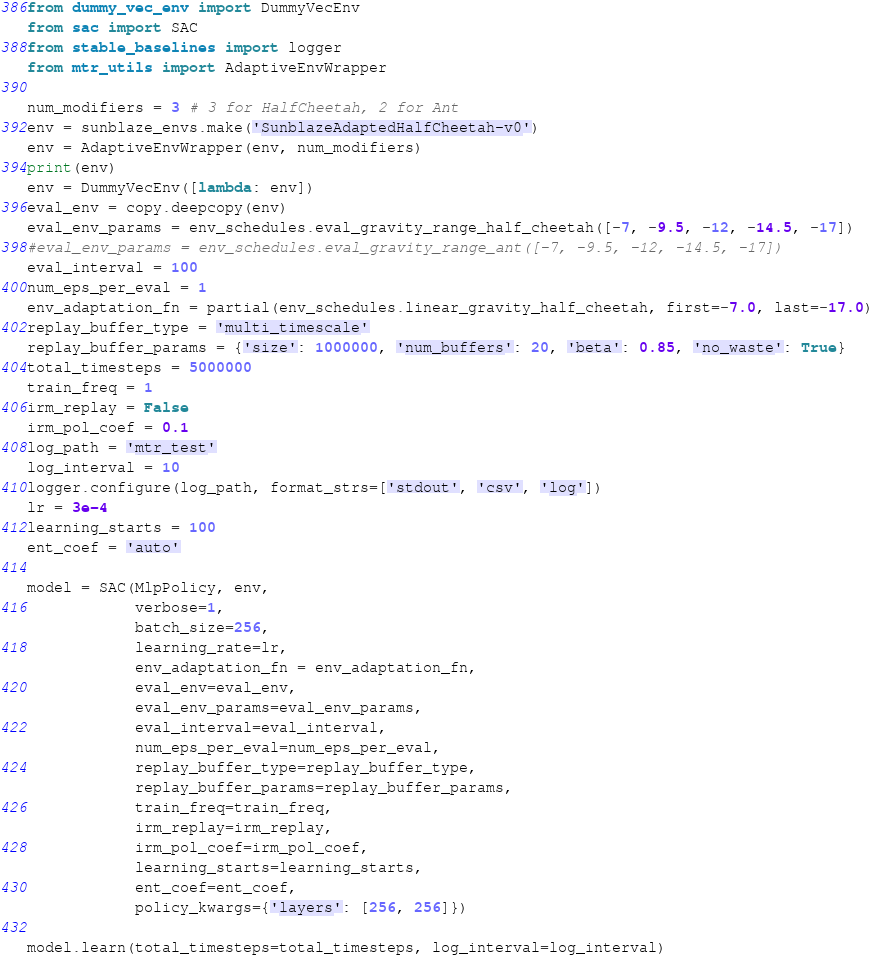<code> <loc_0><loc_0><loc_500><loc_500><_Python_>from dummy_vec_env import DummyVecEnv
from sac import SAC
from stable_baselines import logger
from mtr_utils import AdaptiveEnvWrapper

num_modifiers = 3 # 3 for HalfCheetah, 2 for Ant
env = sunblaze_envs.make('SunblazeAdaptedHalfCheetah-v0')
env = AdaptiveEnvWrapper(env, num_modifiers)
print(env)
env = DummyVecEnv([lambda: env])
eval_env = copy.deepcopy(env)
eval_env_params = env_schedules.eval_gravity_range_half_cheetah([-7, -9.5, -12, -14.5, -17])
#eval_env_params = env_schedules.eval_gravity_range_ant([-7, -9.5, -12, -14.5, -17])
eval_interval = 100
num_eps_per_eval = 1
env_adaptation_fn = partial(env_schedules.linear_gravity_half_cheetah, first=-7.0, last=-17.0)
replay_buffer_type = 'multi_timescale'
replay_buffer_params = {'size': 1000000, 'num_buffers': 20, 'beta': 0.85, 'no_waste': True}
total_timesteps = 5000000
train_freq = 1
irm_replay = False
irm_pol_coef = 0.1
log_path = 'mtr_test'
log_interval = 10
logger.configure(log_path, format_strs=['stdout', 'csv', 'log'])
lr = 3e-4
learning_starts = 100
ent_coef = 'auto'

model = SAC(MlpPolicy, env,
            verbose=1,
            batch_size=256,
            learning_rate=lr,
            env_adaptation_fn = env_adaptation_fn,
            eval_env=eval_env,
            eval_env_params=eval_env_params,
            eval_interval=eval_interval,
            num_eps_per_eval=num_eps_per_eval,
            replay_buffer_type=replay_buffer_type,
            replay_buffer_params=replay_buffer_params,
            train_freq=train_freq,
            irm_replay=irm_replay,
            irm_pol_coef=irm_pol_coef,
            learning_starts=learning_starts,
            ent_coef=ent_coef,
            policy_kwargs={'layers': [256, 256]})

model.learn(total_timesteps=total_timesteps, log_interval=log_interval)
</code> 